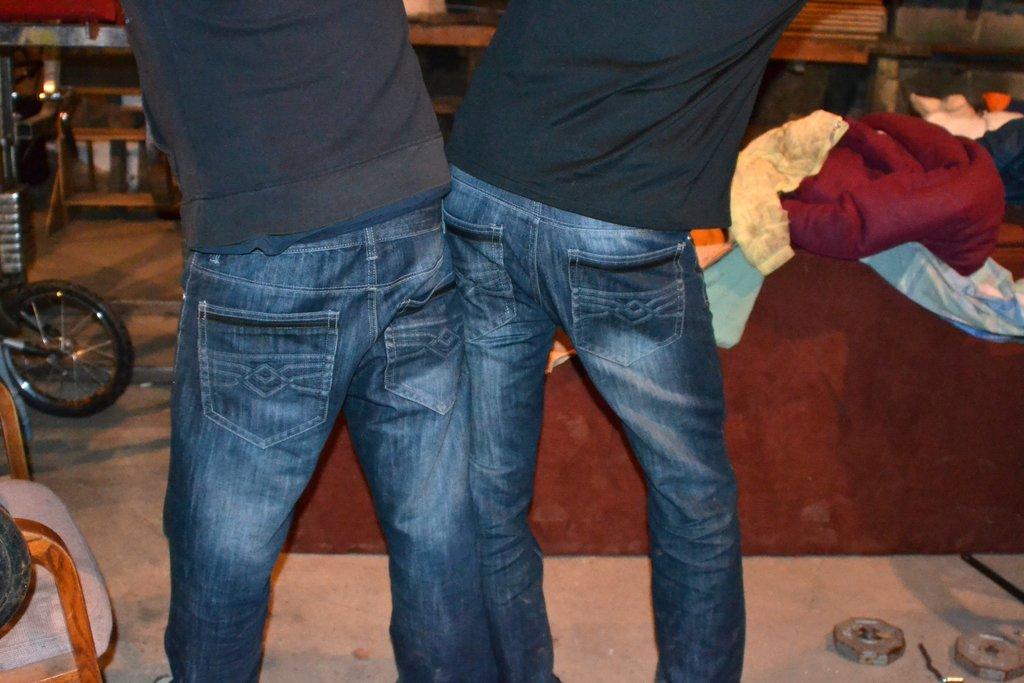Could you give a brief overview of what you see in this image? In the foreground of this image, there are two persons standing on the ground and in the background, we can see a red carpet and a red bean bag on right side of the image. On right bottom corner, we can see few nuts on the ground. On left, we can see a tier of a vehicle, a chair and few objects in the shelf. 